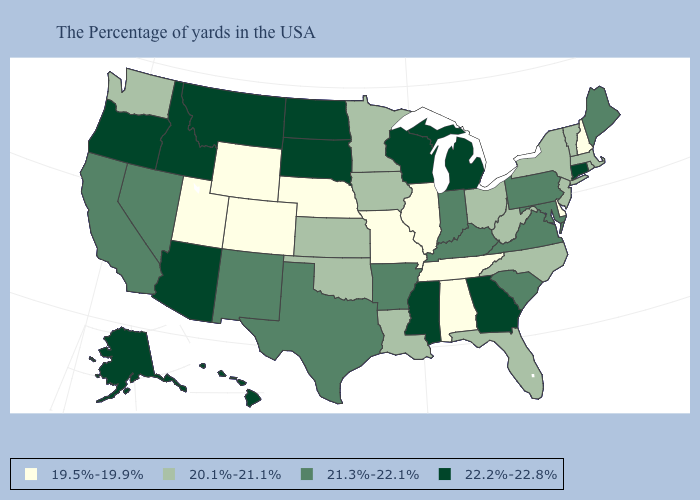How many symbols are there in the legend?
Write a very short answer. 4. How many symbols are there in the legend?
Give a very brief answer. 4. What is the lowest value in the West?
Write a very short answer. 19.5%-19.9%. Among the states that border California , which have the highest value?
Concise answer only. Arizona, Oregon. Does the map have missing data?
Answer briefly. No. Name the states that have a value in the range 22.2%-22.8%?
Concise answer only. Connecticut, Georgia, Michigan, Wisconsin, Mississippi, South Dakota, North Dakota, Montana, Arizona, Idaho, Oregon, Alaska, Hawaii. What is the value of Montana?
Concise answer only. 22.2%-22.8%. Name the states that have a value in the range 22.2%-22.8%?
Write a very short answer. Connecticut, Georgia, Michigan, Wisconsin, Mississippi, South Dakota, North Dakota, Montana, Arizona, Idaho, Oregon, Alaska, Hawaii. Does Minnesota have the same value as West Virginia?
Write a very short answer. Yes. Name the states that have a value in the range 21.3%-22.1%?
Concise answer only. Maine, Maryland, Pennsylvania, Virginia, South Carolina, Kentucky, Indiana, Arkansas, Texas, New Mexico, Nevada, California. What is the value of Delaware?
Quick response, please. 19.5%-19.9%. Does North Dakota have the highest value in the MidWest?
Write a very short answer. Yes. Which states hav the highest value in the MidWest?
Short answer required. Michigan, Wisconsin, South Dakota, North Dakota. Does New Jersey have the same value as Michigan?
Answer briefly. No. Does Utah have the same value as New Hampshire?
Keep it brief. Yes. 